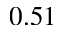<formula> <loc_0><loc_0><loc_500><loc_500>0 . 5 1</formula> 